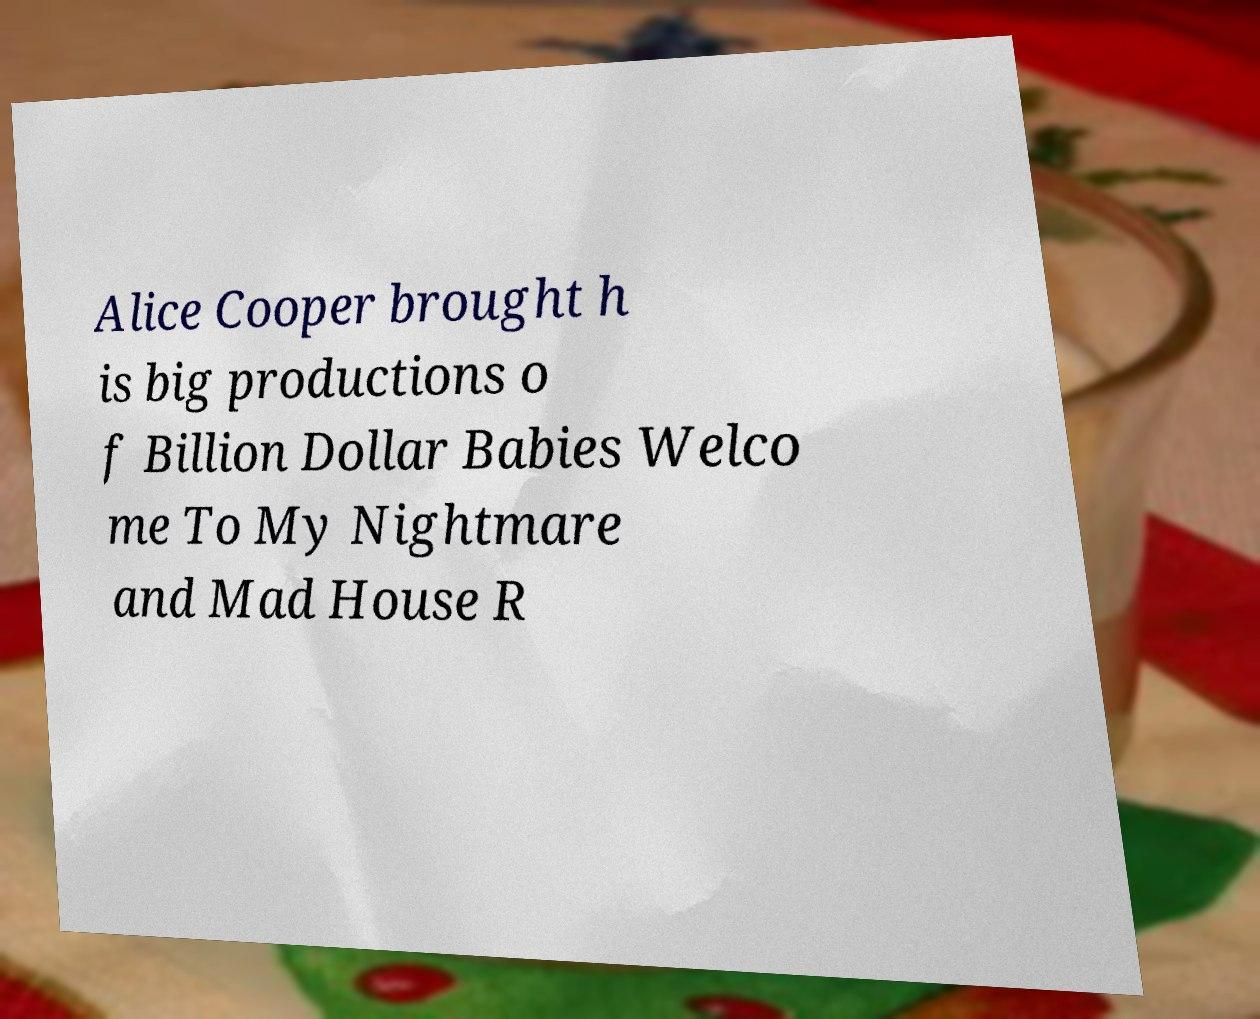For documentation purposes, I need the text within this image transcribed. Could you provide that? Alice Cooper brought h is big productions o f Billion Dollar Babies Welco me To My Nightmare and Mad House R 